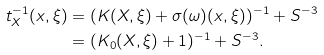<formula> <loc_0><loc_0><loc_500><loc_500>t ^ { - 1 } _ { X } ( x , \xi ) & = ( K ( X , \xi ) + \sigma ( \omega ) ( x , \xi ) ) ^ { - 1 } + S ^ { - 3 } \\ & = ( K _ { 0 } ( X , \xi ) + 1 ) ^ { - 1 } + S ^ { - 3 } .</formula> 